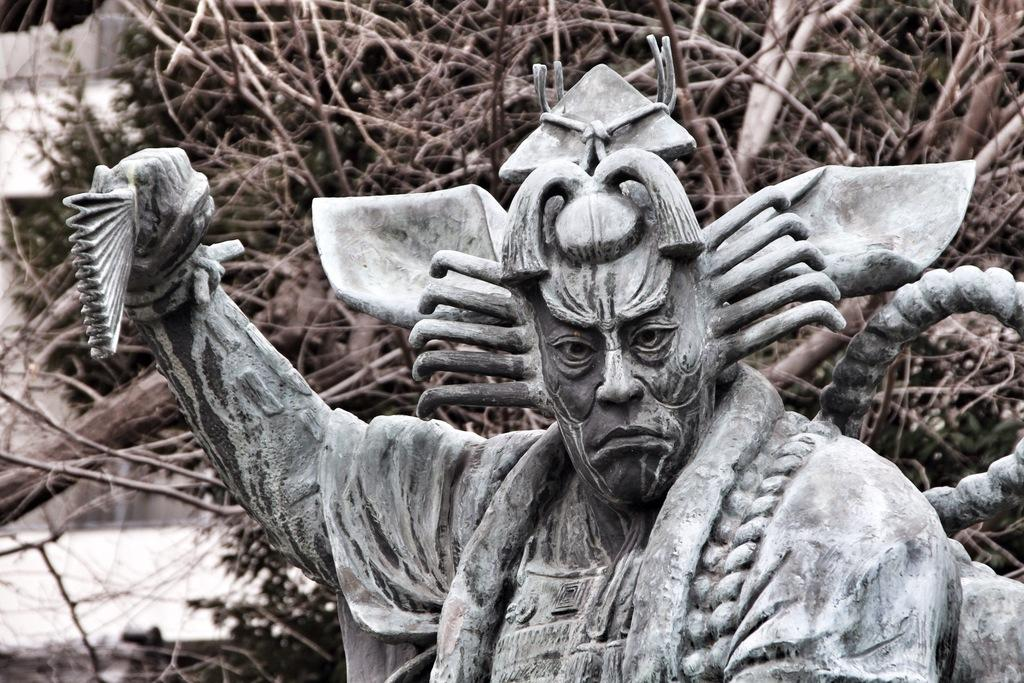What is the main subject of the image? There is a statue of a person in the image. What can be seen in the background of the image? There are branches visible in the background of the image. Where is the faucet located in the image? There is no faucet present in the image. What type of brick is used to construct the statue in the image? The statue is not made of brick; it is a statue of a person, and the material is not specified in the image. 